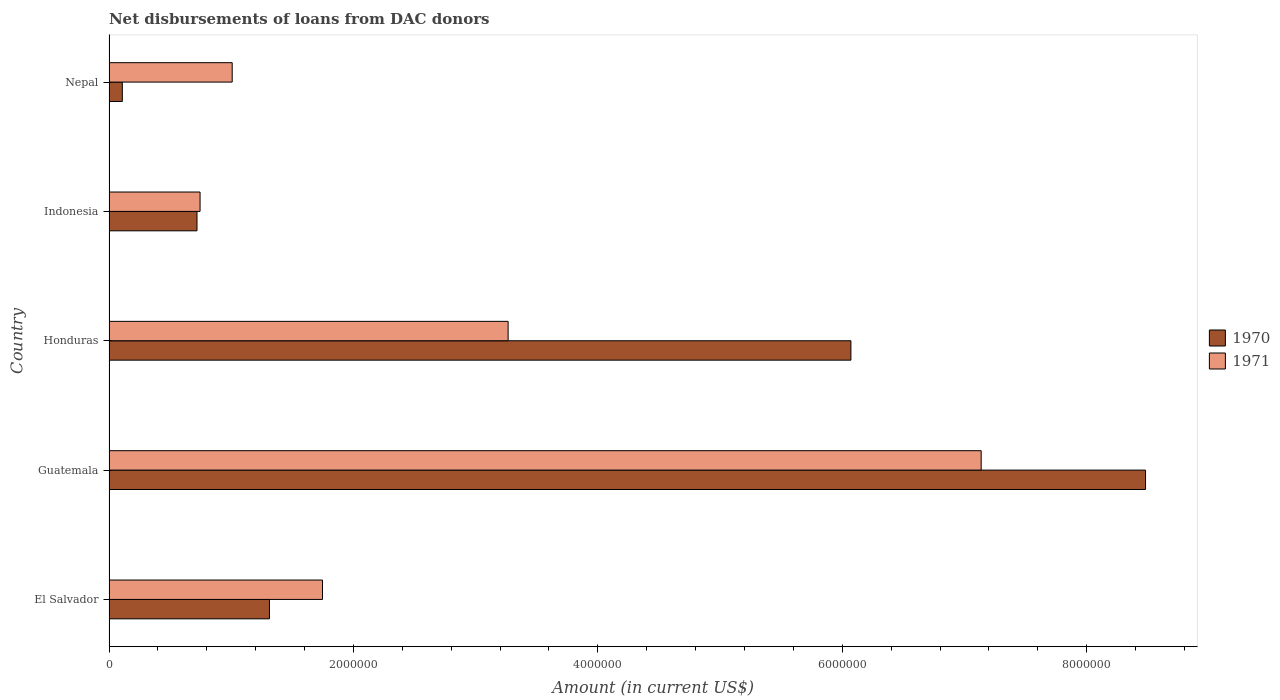How many groups of bars are there?
Keep it short and to the point. 5. Are the number of bars on each tick of the Y-axis equal?
Your answer should be compact. Yes. How many bars are there on the 4th tick from the bottom?
Make the answer very short. 2. What is the label of the 1st group of bars from the top?
Offer a terse response. Nepal. In how many cases, is the number of bars for a given country not equal to the number of legend labels?
Keep it short and to the point. 0. What is the amount of loans disbursed in 1971 in Nepal?
Provide a succinct answer. 1.01e+06. Across all countries, what is the maximum amount of loans disbursed in 1971?
Offer a terse response. 7.14e+06. Across all countries, what is the minimum amount of loans disbursed in 1970?
Give a very brief answer. 1.09e+05. In which country was the amount of loans disbursed in 1970 maximum?
Your answer should be very brief. Guatemala. In which country was the amount of loans disbursed in 1970 minimum?
Make the answer very short. Nepal. What is the total amount of loans disbursed in 1970 in the graph?
Give a very brief answer. 1.67e+07. What is the difference between the amount of loans disbursed in 1971 in Honduras and that in Nepal?
Provide a short and direct response. 2.26e+06. What is the difference between the amount of loans disbursed in 1970 in Honduras and the amount of loans disbursed in 1971 in Nepal?
Provide a short and direct response. 5.06e+06. What is the average amount of loans disbursed in 1971 per country?
Your answer should be very brief. 2.78e+06. What is the difference between the amount of loans disbursed in 1970 and amount of loans disbursed in 1971 in Indonesia?
Your answer should be very brief. -2.50e+04. In how many countries, is the amount of loans disbursed in 1970 greater than 3200000 US$?
Your answer should be very brief. 2. What is the ratio of the amount of loans disbursed in 1970 in Indonesia to that in Nepal?
Keep it short and to the point. 6.61. Is the amount of loans disbursed in 1970 in El Salvador less than that in Honduras?
Provide a short and direct response. Yes. Is the difference between the amount of loans disbursed in 1970 in Guatemala and Nepal greater than the difference between the amount of loans disbursed in 1971 in Guatemala and Nepal?
Your response must be concise. Yes. What is the difference between the highest and the second highest amount of loans disbursed in 1971?
Your answer should be very brief. 3.87e+06. What is the difference between the highest and the lowest amount of loans disbursed in 1971?
Ensure brevity in your answer.  6.39e+06. In how many countries, is the amount of loans disbursed in 1971 greater than the average amount of loans disbursed in 1971 taken over all countries?
Offer a very short reply. 2. Is the sum of the amount of loans disbursed in 1971 in Honduras and Indonesia greater than the maximum amount of loans disbursed in 1970 across all countries?
Give a very brief answer. No. What does the 1st bar from the top in Indonesia represents?
Keep it short and to the point. 1971. Are all the bars in the graph horizontal?
Your answer should be compact. Yes. How many countries are there in the graph?
Provide a succinct answer. 5. Are the values on the major ticks of X-axis written in scientific E-notation?
Keep it short and to the point. No. Does the graph contain any zero values?
Your response must be concise. No. Does the graph contain grids?
Give a very brief answer. No. How are the legend labels stacked?
Provide a short and direct response. Vertical. What is the title of the graph?
Offer a terse response. Net disbursements of loans from DAC donors. What is the label or title of the X-axis?
Offer a terse response. Amount (in current US$). What is the label or title of the Y-axis?
Provide a succinct answer. Country. What is the Amount (in current US$) in 1970 in El Salvador?
Make the answer very short. 1.31e+06. What is the Amount (in current US$) in 1971 in El Salvador?
Offer a terse response. 1.75e+06. What is the Amount (in current US$) in 1970 in Guatemala?
Offer a very short reply. 8.48e+06. What is the Amount (in current US$) in 1971 in Guatemala?
Your answer should be compact. 7.14e+06. What is the Amount (in current US$) of 1970 in Honduras?
Your answer should be very brief. 6.07e+06. What is the Amount (in current US$) of 1971 in Honduras?
Offer a terse response. 3.27e+06. What is the Amount (in current US$) of 1970 in Indonesia?
Offer a very short reply. 7.20e+05. What is the Amount (in current US$) of 1971 in Indonesia?
Your response must be concise. 7.45e+05. What is the Amount (in current US$) in 1970 in Nepal?
Your answer should be very brief. 1.09e+05. What is the Amount (in current US$) of 1971 in Nepal?
Provide a short and direct response. 1.01e+06. Across all countries, what is the maximum Amount (in current US$) in 1970?
Provide a short and direct response. 8.48e+06. Across all countries, what is the maximum Amount (in current US$) in 1971?
Ensure brevity in your answer.  7.14e+06. Across all countries, what is the minimum Amount (in current US$) in 1970?
Provide a succinct answer. 1.09e+05. Across all countries, what is the minimum Amount (in current US$) of 1971?
Keep it short and to the point. 7.45e+05. What is the total Amount (in current US$) of 1970 in the graph?
Make the answer very short. 1.67e+07. What is the total Amount (in current US$) in 1971 in the graph?
Keep it short and to the point. 1.39e+07. What is the difference between the Amount (in current US$) of 1970 in El Salvador and that in Guatemala?
Provide a short and direct response. -7.17e+06. What is the difference between the Amount (in current US$) of 1971 in El Salvador and that in Guatemala?
Ensure brevity in your answer.  -5.39e+06. What is the difference between the Amount (in current US$) of 1970 in El Salvador and that in Honduras?
Provide a short and direct response. -4.76e+06. What is the difference between the Amount (in current US$) of 1971 in El Salvador and that in Honduras?
Your answer should be compact. -1.52e+06. What is the difference between the Amount (in current US$) in 1970 in El Salvador and that in Indonesia?
Your answer should be very brief. 5.93e+05. What is the difference between the Amount (in current US$) in 1971 in El Salvador and that in Indonesia?
Your answer should be compact. 1.00e+06. What is the difference between the Amount (in current US$) in 1970 in El Salvador and that in Nepal?
Your answer should be compact. 1.20e+06. What is the difference between the Amount (in current US$) in 1971 in El Salvador and that in Nepal?
Ensure brevity in your answer.  7.39e+05. What is the difference between the Amount (in current US$) of 1970 in Guatemala and that in Honduras?
Offer a terse response. 2.41e+06. What is the difference between the Amount (in current US$) of 1971 in Guatemala and that in Honduras?
Ensure brevity in your answer.  3.87e+06. What is the difference between the Amount (in current US$) of 1970 in Guatemala and that in Indonesia?
Provide a short and direct response. 7.76e+06. What is the difference between the Amount (in current US$) in 1971 in Guatemala and that in Indonesia?
Offer a terse response. 6.39e+06. What is the difference between the Amount (in current US$) in 1970 in Guatemala and that in Nepal?
Your answer should be very brief. 8.37e+06. What is the difference between the Amount (in current US$) in 1971 in Guatemala and that in Nepal?
Provide a succinct answer. 6.13e+06. What is the difference between the Amount (in current US$) of 1970 in Honduras and that in Indonesia?
Your answer should be compact. 5.35e+06. What is the difference between the Amount (in current US$) in 1971 in Honduras and that in Indonesia?
Give a very brief answer. 2.52e+06. What is the difference between the Amount (in current US$) in 1970 in Honduras and that in Nepal?
Offer a very short reply. 5.96e+06. What is the difference between the Amount (in current US$) in 1971 in Honduras and that in Nepal?
Give a very brief answer. 2.26e+06. What is the difference between the Amount (in current US$) of 1970 in Indonesia and that in Nepal?
Make the answer very short. 6.11e+05. What is the difference between the Amount (in current US$) in 1971 in Indonesia and that in Nepal?
Offer a very short reply. -2.63e+05. What is the difference between the Amount (in current US$) in 1970 in El Salvador and the Amount (in current US$) in 1971 in Guatemala?
Offer a very short reply. -5.82e+06. What is the difference between the Amount (in current US$) of 1970 in El Salvador and the Amount (in current US$) of 1971 in Honduras?
Provide a short and direct response. -1.95e+06. What is the difference between the Amount (in current US$) in 1970 in El Salvador and the Amount (in current US$) in 1971 in Indonesia?
Give a very brief answer. 5.68e+05. What is the difference between the Amount (in current US$) in 1970 in El Salvador and the Amount (in current US$) in 1971 in Nepal?
Keep it short and to the point. 3.05e+05. What is the difference between the Amount (in current US$) in 1970 in Guatemala and the Amount (in current US$) in 1971 in Honduras?
Offer a very short reply. 5.22e+06. What is the difference between the Amount (in current US$) in 1970 in Guatemala and the Amount (in current US$) in 1971 in Indonesia?
Keep it short and to the point. 7.74e+06. What is the difference between the Amount (in current US$) of 1970 in Guatemala and the Amount (in current US$) of 1971 in Nepal?
Provide a succinct answer. 7.47e+06. What is the difference between the Amount (in current US$) in 1970 in Honduras and the Amount (in current US$) in 1971 in Indonesia?
Your answer should be compact. 5.33e+06. What is the difference between the Amount (in current US$) in 1970 in Honduras and the Amount (in current US$) in 1971 in Nepal?
Make the answer very short. 5.06e+06. What is the difference between the Amount (in current US$) in 1970 in Indonesia and the Amount (in current US$) in 1971 in Nepal?
Your answer should be compact. -2.88e+05. What is the average Amount (in current US$) of 1970 per country?
Give a very brief answer. 3.34e+06. What is the average Amount (in current US$) of 1971 per country?
Ensure brevity in your answer.  2.78e+06. What is the difference between the Amount (in current US$) in 1970 and Amount (in current US$) in 1971 in El Salvador?
Offer a very short reply. -4.34e+05. What is the difference between the Amount (in current US$) in 1970 and Amount (in current US$) in 1971 in Guatemala?
Your answer should be compact. 1.34e+06. What is the difference between the Amount (in current US$) of 1970 and Amount (in current US$) of 1971 in Honduras?
Give a very brief answer. 2.80e+06. What is the difference between the Amount (in current US$) in 1970 and Amount (in current US$) in 1971 in Indonesia?
Provide a succinct answer. -2.50e+04. What is the difference between the Amount (in current US$) of 1970 and Amount (in current US$) of 1971 in Nepal?
Make the answer very short. -8.99e+05. What is the ratio of the Amount (in current US$) of 1970 in El Salvador to that in Guatemala?
Provide a succinct answer. 0.15. What is the ratio of the Amount (in current US$) in 1971 in El Salvador to that in Guatemala?
Give a very brief answer. 0.24. What is the ratio of the Amount (in current US$) in 1970 in El Salvador to that in Honduras?
Provide a short and direct response. 0.22. What is the ratio of the Amount (in current US$) of 1971 in El Salvador to that in Honduras?
Provide a succinct answer. 0.53. What is the ratio of the Amount (in current US$) in 1970 in El Salvador to that in Indonesia?
Offer a terse response. 1.82. What is the ratio of the Amount (in current US$) in 1971 in El Salvador to that in Indonesia?
Your response must be concise. 2.35. What is the ratio of the Amount (in current US$) in 1970 in El Salvador to that in Nepal?
Offer a terse response. 12.05. What is the ratio of the Amount (in current US$) in 1971 in El Salvador to that in Nepal?
Ensure brevity in your answer.  1.73. What is the ratio of the Amount (in current US$) of 1970 in Guatemala to that in Honduras?
Provide a short and direct response. 1.4. What is the ratio of the Amount (in current US$) in 1971 in Guatemala to that in Honduras?
Make the answer very short. 2.19. What is the ratio of the Amount (in current US$) in 1970 in Guatemala to that in Indonesia?
Make the answer very short. 11.78. What is the ratio of the Amount (in current US$) in 1971 in Guatemala to that in Indonesia?
Offer a very short reply. 9.58. What is the ratio of the Amount (in current US$) of 1970 in Guatemala to that in Nepal?
Give a very brief answer. 77.82. What is the ratio of the Amount (in current US$) in 1971 in Guatemala to that in Nepal?
Provide a succinct answer. 7.08. What is the ratio of the Amount (in current US$) of 1970 in Honduras to that in Indonesia?
Provide a succinct answer. 8.43. What is the ratio of the Amount (in current US$) in 1971 in Honduras to that in Indonesia?
Offer a terse response. 4.38. What is the ratio of the Amount (in current US$) of 1970 in Honduras to that in Nepal?
Your answer should be very brief. 55.7. What is the ratio of the Amount (in current US$) of 1971 in Honduras to that in Nepal?
Provide a succinct answer. 3.24. What is the ratio of the Amount (in current US$) of 1970 in Indonesia to that in Nepal?
Offer a terse response. 6.61. What is the ratio of the Amount (in current US$) in 1971 in Indonesia to that in Nepal?
Ensure brevity in your answer.  0.74. What is the difference between the highest and the second highest Amount (in current US$) of 1970?
Your response must be concise. 2.41e+06. What is the difference between the highest and the second highest Amount (in current US$) of 1971?
Provide a succinct answer. 3.87e+06. What is the difference between the highest and the lowest Amount (in current US$) in 1970?
Offer a very short reply. 8.37e+06. What is the difference between the highest and the lowest Amount (in current US$) of 1971?
Offer a terse response. 6.39e+06. 